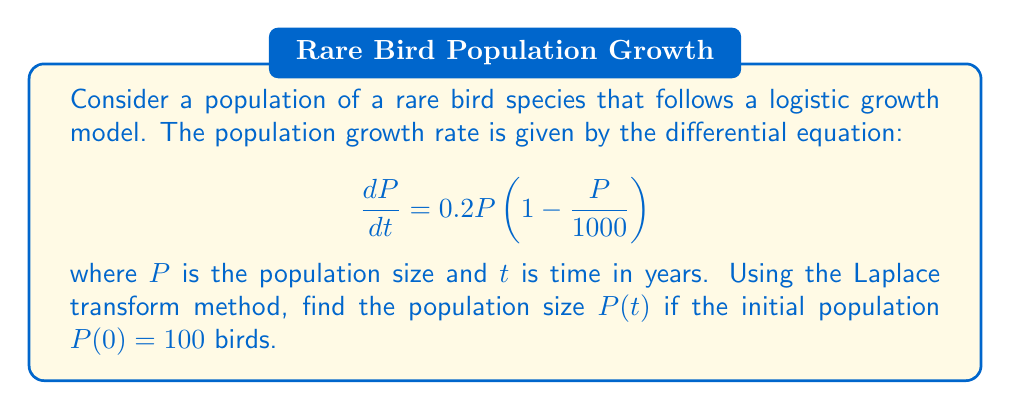Help me with this question. Let's solve this step-by-step using the Laplace transform method:

1) First, we take the Laplace transform of both sides of the equation:

   $$\mathcal{L}\left\{\frac{dP}{dt}\right\} = \mathcal{L}\left\{0.2P - \frac{0.2P^2}{1000}\right\}$$

2) Using the linearity property and the Laplace transform of the derivative:

   $$s\mathcal{L}\{P\} - P(0) = 0.2\mathcal{L}\{P\} - \frac{0.2}{1000}\mathcal{L}\{P^2\}$$

3) Let $\mathcal{L}\{P\} = F(s)$. Substituting the initial condition $P(0) = 100$:

   $$sF(s) - 100 = 0.2F(s) - \frac{0.2}{1000}\mathcal{L}\{P^2\}$$

4) The term $\mathcal{L}\{P^2\}$ makes this equation nonlinear and difficult to solve directly. We can approximate it using the initial condition:

   $$P^2 \approx 2P_0P - P_0^2 = 200P - 10000$$

5) Taking the Laplace transform of this approximation:

   $$\mathcal{L}\{P^2\} \approx 200F(s) - \frac{10000}{s}$$

6) Substituting this back into our equation:

   $$sF(s) - 100 = 0.2F(s) - \frac{0.2}{1000}\left(200F(s) - \frac{10000}{s}\right)$$

7) Simplifying:

   $$sF(s) - 100 = 0.2F(s) - 0.04F(s) + \frac{2}{s}$$

   $$(s - 0.16)F(s) = 100 + \frac{2}{s}$$

8) Solving for $F(s)$:

   $$F(s) = \frac{100s + 2}{s(s - 0.16)}$$

9) This can be decomposed into partial fractions:

   $$F(s) = \frac{A}{s} + \frac{B}{s - 0.16}$$

   where $A = 625$ and $B = -525$

10) Taking the inverse Laplace transform:

    $$P(t) = 625 - 525e^{0.16t}$$

This is the solution for the population size $P(t)$ at time $t$.
Answer: $P(t) = 625 - 525e^{0.16t}$ 